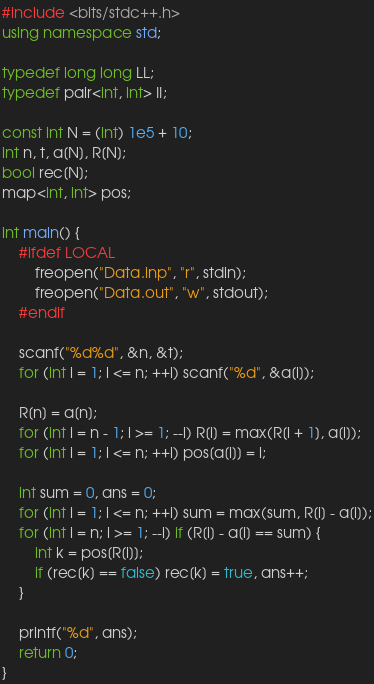Convert code to text. <code><loc_0><loc_0><loc_500><loc_500><_C++_>#include <bits/stdc++.h>
using namespace std;

typedef long long LL;
typedef pair<int, int> II;

const int N = (int) 1e5 + 10;
int n, t, a[N], R[N];
bool rec[N];
map<int, int> pos;

int main() {
    #ifdef LOCAL
        freopen("Data.inp", "r", stdin);
        freopen("Data.out", "w", stdout);
    #endif

    scanf("%d%d", &n, &t);
    for (int i = 1; i <= n; ++i) scanf("%d", &a[i]);

    R[n] = a[n];
    for (int i = n - 1; i >= 1; --i) R[i] = max(R[i + 1], a[i]);
    for (int i = 1; i <= n; ++i) pos[a[i]] = i;

    int sum = 0, ans = 0;
    for (int i = 1; i <= n; ++i) sum = max(sum, R[i] - a[i]);
    for (int i = n; i >= 1; --i) if (R[i] - a[i] == sum) {
        int k = pos[R[i]];
        if (rec[k] == false) rec[k] = true, ans++;
    }

    printf("%d", ans);
    return 0;
}
</code> 